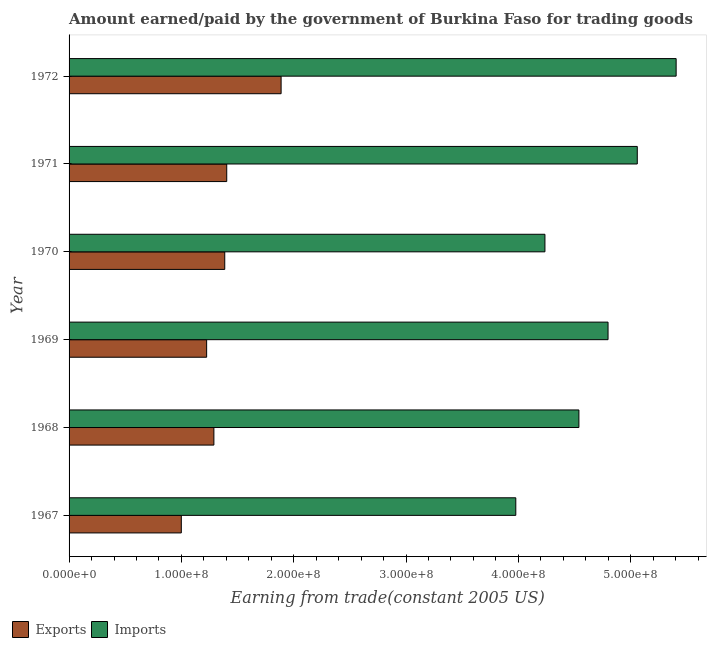How many different coloured bars are there?
Provide a short and direct response. 2. How many bars are there on the 3rd tick from the bottom?
Your answer should be compact. 2. What is the label of the 2nd group of bars from the top?
Make the answer very short. 1971. What is the amount paid for imports in 1967?
Give a very brief answer. 3.98e+08. Across all years, what is the maximum amount earned from exports?
Offer a very short reply. 1.89e+08. Across all years, what is the minimum amount earned from exports?
Offer a very short reply. 9.99e+07. In which year was the amount earned from exports minimum?
Provide a succinct answer. 1967. What is the total amount earned from exports in the graph?
Offer a terse response. 8.19e+08. What is the difference between the amount earned from exports in 1969 and that in 1970?
Ensure brevity in your answer.  -1.61e+07. What is the difference between the amount paid for imports in 1967 and the amount earned from exports in 1970?
Your answer should be compact. 2.59e+08. What is the average amount paid for imports per year?
Your response must be concise. 4.67e+08. In the year 1967, what is the difference between the amount paid for imports and amount earned from exports?
Offer a terse response. 2.98e+08. What is the ratio of the amount paid for imports in 1971 to that in 1972?
Make the answer very short. 0.94. Is the difference between the amount paid for imports in 1971 and 1972 greater than the difference between the amount earned from exports in 1971 and 1972?
Your response must be concise. Yes. What is the difference between the highest and the second highest amount earned from exports?
Offer a terse response. 4.84e+07. What is the difference between the highest and the lowest amount earned from exports?
Give a very brief answer. 8.88e+07. Is the sum of the amount earned from exports in 1968 and 1971 greater than the maximum amount paid for imports across all years?
Offer a terse response. No. What does the 2nd bar from the top in 1970 represents?
Give a very brief answer. Exports. What does the 2nd bar from the bottom in 1971 represents?
Keep it short and to the point. Imports. How many bars are there?
Make the answer very short. 12. How many years are there in the graph?
Provide a succinct answer. 6. Are the values on the major ticks of X-axis written in scientific E-notation?
Offer a terse response. Yes. Where does the legend appear in the graph?
Keep it short and to the point. Bottom left. What is the title of the graph?
Make the answer very short. Amount earned/paid by the government of Burkina Faso for trading goods. Does "Time to export" appear as one of the legend labels in the graph?
Your answer should be very brief. No. What is the label or title of the X-axis?
Offer a terse response. Earning from trade(constant 2005 US). What is the label or title of the Y-axis?
Your answer should be very brief. Year. What is the Earning from trade(constant 2005 US) in Exports in 1967?
Provide a succinct answer. 9.99e+07. What is the Earning from trade(constant 2005 US) of Imports in 1967?
Ensure brevity in your answer.  3.98e+08. What is the Earning from trade(constant 2005 US) in Exports in 1968?
Your answer should be compact. 1.29e+08. What is the Earning from trade(constant 2005 US) in Imports in 1968?
Ensure brevity in your answer.  4.54e+08. What is the Earning from trade(constant 2005 US) of Exports in 1969?
Offer a very short reply. 1.22e+08. What is the Earning from trade(constant 2005 US) of Imports in 1969?
Give a very brief answer. 4.80e+08. What is the Earning from trade(constant 2005 US) of Exports in 1970?
Your response must be concise. 1.39e+08. What is the Earning from trade(constant 2005 US) of Imports in 1970?
Offer a very short reply. 4.24e+08. What is the Earning from trade(constant 2005 US) in Exports in 1971?
Your response must be concise. 1.40e+08. What is the Earning from trade(constant 2005 US) in Imports in 1971?
Provide a short and direct response. 5.06e+08. What is the Earning from trade(constant 2005 US) in Exports in 1972?
Offer a very short reply. 1.89e+08. What is the Earning from trade(constant 2005 US) in Imports in 1972?
Keep it short and to the point. 5.40e+08. Across all years, what is the maximum Earning from trade(constant 2005 US) of Exports?
Offer a very short reply. 1.89e+08. Across all years, what is the maximum Earning from trade(constant 2005 US) of Imports?
Provide a short and direct response. 5.40e+08. Across all years, what is the minimum Earning from trade(constant 2005 US) in Exports?
Provide a succinct answer. 9.99e+07. Across all years, what is the minimum Earning from trade(constant 2005 US) in Imports?
Ensure brevity in your answer.  3.98e+08. What is the total Earning from trade(constant 2005 US) of Exports in the graph?
Offer a very short reply. 8.19e+08. What is the total Earning from trade(constant 2005 US) in Imports in the graph?
Your response must be concise. 2.80e+09. What is the difference between the Earning from trade(constant 2005 US) of Exports in 1967 and that in 1968?
Ensure brevity in your answer.  -2.90e+07. What is the difference between the Earning from trade(constant 2005 US) in Imports in 1967 and that in 1968?
Offer a terse response. -5.62e+07. What is the difference between the Earning from trade(constant 2005 US) of Exports in 1967 and that in 1969?
Offer a terse response. -2.26e+07. What is the difference between the Earning from trade(constant 2005 US) of Imports in 1967 and that in 1969?
Make the answer very short. -8.21e+07. What is the difference between the Earning from trade(constant 2005 US) in Exports in 1967 and that in 1970?
Provide a succinct answer. -3.87e+07. What is the difference between the Earning from trade(constant 2005 US) of Imports in 1967 and that in 1970?
Ensure brevity in your answer.  -2.59e+07. What is the difference between the Earning from trade(constant 2005 US) in Exports in 1967 and that in 1971?
Provide a succinct answer. -4.04e+07. What is the difference between the Earning from trade(constant 2005 US) in Imports in 1967 and that in 1971?
Ensure brevity in your answer.  -1.08e+08. What is the difference between the Earning from trade(constant 2005 US) in Exports in 1967 and that in 1972?
Offer a terse response. -8.88e+07. What is the difference between the Earning from trade(constant 2005 US) of Imports in 1967 and that in 1972?
Your answer should be very brief. -1.43e+08. What is the difference between the Earning from trade(constant 2005 US) of Exports in 1968 and that in 1969?
Keep it short and to the point. 6.45e+06. What is the difference between the Earning from trade(constant 2005 US) of Imports in 1968 and that in 1969?
Your answer should be very brief. -2.59e+07. What is the difference between the Earning from trade(constant 2005 US) of Exports in 1968 and that in 1970?
Give a very brief answer. -9.67e+06. What is the difference between the Earning from trade(constant 2005 US) in Imports in 1968 and that in 1970?
Provide a short and direct response. 3.03e+07. What is the difference between the Earning from trade(constant 2005 US) of Exports in 1968 and that in 1971?
Your answer should be very brief. -1.14e+07. What is the difference between the Earning from trade(constant 2005 US) in Imports in 1968 and that in 1971?
Ensure brevity in your answer.  -5.20e+07. What is the difference between the Earning from trade(constant 2005 US) of Exports in 1968 and that in 1972?
Offer a very short reply. -5.98e+07. What is the difference between the Earning from trade(constant 2005 US) of Imports in 1968 and that in 1972?
Your answer should be very brief. -8.66e+07. What is the difference between the Earning from trade(constant 2005 US) in Exports in 1969 and that in 1970?
Your response must be concise. -1.61e+07. What is the difference between the Earning from trade(constant 2005 US) of Imports in 1969 and that in 1970?
Make the answer very short. 5.62e+07. What is the difference between the Earning from trade(constant 2005 US) in Exports in 1969 and that in 1971?
Provide a short and direct response. -1.79e+07. What is the difference between the Earning from trade(constant 2005 US) in Imports in 1969 and that in 1971?
Provide a succinct answer. -2.60e+07. What is the difference between the Earning from trade(constant 2005 US) in Exports in 1969 and that in 1972?
Offer a terse response. -6.63e+07. What is the difference between the Earning from trade(constant 2005 US) in Imports in 1969 and that in 1972?
Your response must be concise. -6.06e+07. What is the difference between the Earning from trade(constant 2005 US) of Exports in 1970 and that in 1971?
Offer a very short reply. -1.77e+06. What is the difference between the Earning from trade(constant 2005 US) of Imports in 1970 and that in 1971?
Your answer should be compact. -8.22e+07. What is the difference between the Earning from trade(constant 2005 US) of Exports in 1970 and that in 1972?
Your answer should be compact. -5.02e+07. What is the difference between the Earning from trade(constant 2005 US) of Imports in 1970 and that in 1972?
Keep it short and to the point. -1.17e+08. What is the difference between the Earning from trade(constant 2005 US) of Exports in 1971 and that in 1972?
Provide a short and direct response. -4.84e+07. What is the difference between the Earning from trade(constant 2005 US) in Imports in 1971 and that in 1972?
Your response must be concise. -3.46e+07. What is the difference between the Earning from trade(constant 2005 US) of Exports in 1967 and the Earning from trade(constant 2005 US) of Imports in 1968?
Your response must be concise. -3.54e+08. What is the difference between the Earning from trade(constant 2005 US) in Exports in 1967 and the Earning from trade(constant 2005 US) in Imports in 1969?
Provide a short and direct response. -3.80e+08. What is the difference between the Earning from trade(constant 2005 US) in Exports in 1967 and the Earning from trade(constant 2005 US) in Imports in 1970?
Give a very brief answer. -3.24e+08. What is the difference between the Earning from trade(constant 2005 US) in Exports in 1967 and the Earning from trade(constant 2005 US) in Imports in 1971?
Provide a succinct answer. -4.06e+08. What is the difference between the Earning from trade(constant 2005 US) of Exports in 1967 and the Earning from trade(constant 2005 US) of Imports in 1972?
Your answer should be very brief. -4.41e+08. What is the difference between the Earning from trade(constant 2005 US) in Exports in 1968 and the Earning from trade(constant 2005 US) in Imports in 1969?
Give a very brief answer. -3.51e+08. What is the difference between the Earning from trade(constant 2005 US) of Exports in 1968 and the Earning from trade(constant 2005 US) of Imports in 1970?
Provide a short and direct response. -2.95e+08. What is the difference between the Earning from trade(constant 2005 US) in Exports in 1968 and the Earning from trade(constant 2005 US) in Imports in 1971?
Ensure brevity in your answer.  -3.77e+08. What is the difference between the Earning from trade(constant 2005 US) in Exports in 1968 and the Earning from trade(constant 2005 US) in Imports in 1972?
Keep it short and to the point. -4.12e+08. What is the difference between the Earning from trade(constant 2005 US) of Exports in 1969 and the Earning from trade(constant 2005 US) of Imports in 1970?
Make the answer very short. -3.01e+08. What is the difference between the Earning from trade(constant 2005 US) in Exports in 1969 and the Earning from trade(constant 2005 US) in Imports in 1971?
Give a very brief answer. -3.83e+08. What is the difference between the Earning from trade(constant 2005 US) of Exports in 1969 and the Earning from trade(constant 2005 US) of Imports in 1972?
Your response must be concise. -4.18e+08. What is the difference between the Earning from trade(constant 2005 US) of Exports in 1970 and the Earning from trade(constant 2005 US) of Imports in 1971?
Your answer should be very brief. -3.67e+08. What is the difference between the Earning from trade(constant 2005 US) in Exports in 1970 and the Earning from trade(constant 2005 US) in Imports in 1972?
Make the answer very short. -4.02e+08. What is the difference between the Earning from trade(constant 2005 US) of Exports in 1971 and the Earning from trade(constant 2005 US) of Imports in 1972?
Offer a very short reply. -4.00e+08. What is the average Earning from trade(constant 2005 US) of Exports per year?
Your response must be concise. 1.37e+08. What is the average Earning from trade(constant 2005 US) in Imports per year?
Your answer should be very brief. 4.67e+08. In the year 1967, what is the difference between the Earning from trade(constant 2005 US) of Exports and Earning from trade(constant 2005 US) of Imports?
Your response must be concise. -2.98e+08. In the year 1968, what is the difference between the Earning from trade(constant 2005 US) in Exports and Earning from trade(constant 2005 US) in Imports?
Provide a succinct answer. -3.25e+08. In the year 1969, what is the difference between the Earning from trade(constant 2005 US) of Exports and Earning from trade(constant 2005 US) of Imports?
Your response must be concise. -3.57e+08. In the year 1970, what is the difference between the Earning from trade(constant 2005 US) in Exports and Earning from trade(constant 2005 US) in Imports?
Offer a terse response. -2.85e+08. In the year 1971, what is the difference between the Earning from trade(constant 2005 US) in Exports and Earning from trade(constant 2005 US) in Imports?
Your answer should be very brief. -3.66e+08. In the year 1972, what is the difference between the Earning from trade(constant 2005 US) of Exports and Earning from trade(constant 2005 US) of Imports?
Offer a terse response. -3.52e+08. What is the ratio of the Earning from trade(constant 2005 US) of Exports in 1967 to that in 1968?
Ensure brevity in your answer.  0.78. What is the ratio of the Earning from trade(constant 2005 US) in Imports in 1967 to that in 1968?
Your answer should be very brief. 0.88. What is the ratio of the Earning from trade(constant 2005 US) in Exports in 1967 to that in 1969?
Your answer should be very brief. 0.82. What is the ratio of the Earning from trade(constant 2005 US) of Imports in 1967 to that in 1969?
Keep it short and to the point. 0.83. What is the ratio of the Earning from trade(constant 2005 US) in Exports in 1967 to that in 1970?
Ensure brevity in your answer.  0.72. What is the ratio of the Earning from trade(constant 2005 US) in Imports in 1967 to that in 1970?
Provide a short and direct response. 0.94. What is the ratio of the Earning from trade(constant 2005 US) in Exports in 1967 to that in 1971?
Provide a succinct answer. 0.71. What is the ratio of the Earning from trade(constant 2005 US) of Imports in 1967 to that in 1971?
Make the answer very short. 0.79. What is the ratio of the Earning from trade(constant 2005 US) of Exports in 1967 to that in 1972?
Provide a succinct answer. 0.53. What is the ratio of the Earning from trade(constant 2005 US) of Imports in 1967 to that in 1972?
Your answer should be very brief. 0.74. What is the ratio of the Earning from trade(constant 2005 US) in Exports in 1968 to that in 1969?
Provide a short and direct response. 1.05. What is the ratio of the Earning from trade(constant 2005 US) of Imports in 1968 to that in 1969?
Give a very brief answer. 0.95. What is the ratio of the Earning from trade(constant 2005 US) of Exports in 1968 to that in 1970?
Offer a terse response. 0.93. What is the ratio of the Earning from trade(constant 2005 US) of Imports in 1968 to that in 1970?
Keep it short and to the point. 1.07. What is the ratio of the Earning from trade(constant 2005 US) in Exports in 1968 to that in 1971?
Provide a short and direct response. 0.92. What is the ratio of the Earning from trade(constant 2005 US) in Imports in 1968 to that in 1971?
Give a very brief answer. 0.9. What is the ratio of the Earning from trade(constant 2005 US) of Exports in 1968 to that in 1972?
Offer a very short reply. 0.68. What is the ratio of the Earning from trade(constant 2005 US) of Imports in 1968 to that in 1972?
Make the answer very short. 0.84. What is the ratio of the Earning from trade(constant 2005 US) in Exports in 1969 to that in 1970?
Provide a succinct answer. 0.88. What is the ratio of the Earning from trade(constant 2005 US) in Imports in 1969 to that in 1970?
Your answer should be very brief. 1.13. What is the ratio of the Earning from trade(constant 2005 US) of Exports in 1969 to that in 1971?
Your answer should be compact. 0.87. What is the ratio of the Earning from trade(constant 2005 US) of Imports in 1969 to that in 1971?
Offer a terse response. 0.95. What is the ratio of the Earning from trade(constant 2005 US) in Exports in 1969 to that in 1972?
Give a very brief answer. 0.65. What is the ratio of the Earning from trade(constant 2005 US) in Imports in 1969 to that in 1972?
Keep it short and to the point. 0.89. What is the ratio of the Earning from trade(constant 2005 US) of Exports in 1970 to that in 1971?
Your answer should be very brief. 0.99. What is the ratio of the Earning from trade(constant 2005 US) of Imports in 1970 to that in 1971?
Your answer should be compact. 0.84. What is the ratio of the Earning from trade(constant 2005 US) of Exports in 1970 to that in 1972?
Offer a very short reply. 0.73. What is the ratio of the Earning from trade(constant 2005 US) in Imports in 1970 to that in 1972?
Offer a terse response. 0.78. What is the ratio of the Earning from trade(constant 2005 US) in Exports in 1971 to that in 1972?
Provide a succinct answer. 0.74. What is the ratio of the Earning from trade(constant 2005 US) in Imports in 1971 to that in 1972?
Your response must be concise. 0.94. What is the difference between the highest and the second highest Earning from trade(constant 2005 US) of Exports?
Your answer should be very brief. 4.84e+07. What is the difference between the highest and the second highest Earning from trade(constant 2005 US) in Imports?
Offer a terse response. 3.46e+07. What is the difference between the highest and the lowest Earning from trade(constant 2005 US) of Exports?
Offer a terse response. 8.88e+07. What is the difference between the highest and the lowest Earning from trade(constant 2005 US) in Imports?
Your answer should be compact. 1.43e+08. 